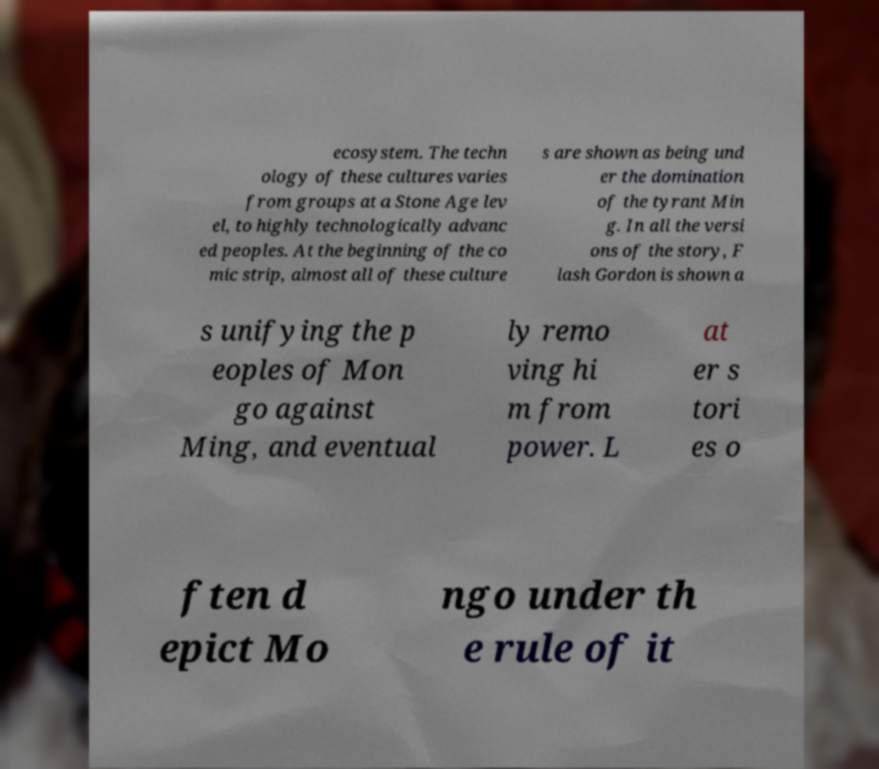I need the written content from this picture converted into text. Can you do that? ecosystem. The techn ology of these cultures varies from groups at a Stone Age lev el, to highly technologically advanc ed peoples. At the beginning of the co mic strip, almost all of these culture s are shown as being und er the domination of the tyrant Min g. In all the versi ons of the story, F lash Gordon is shown a s unifying the p eoples of Mon go against Ming, and eventual ly remo ving hi m from power. L at er s tori es o ften d epict Mo ngo under th e rule of it 